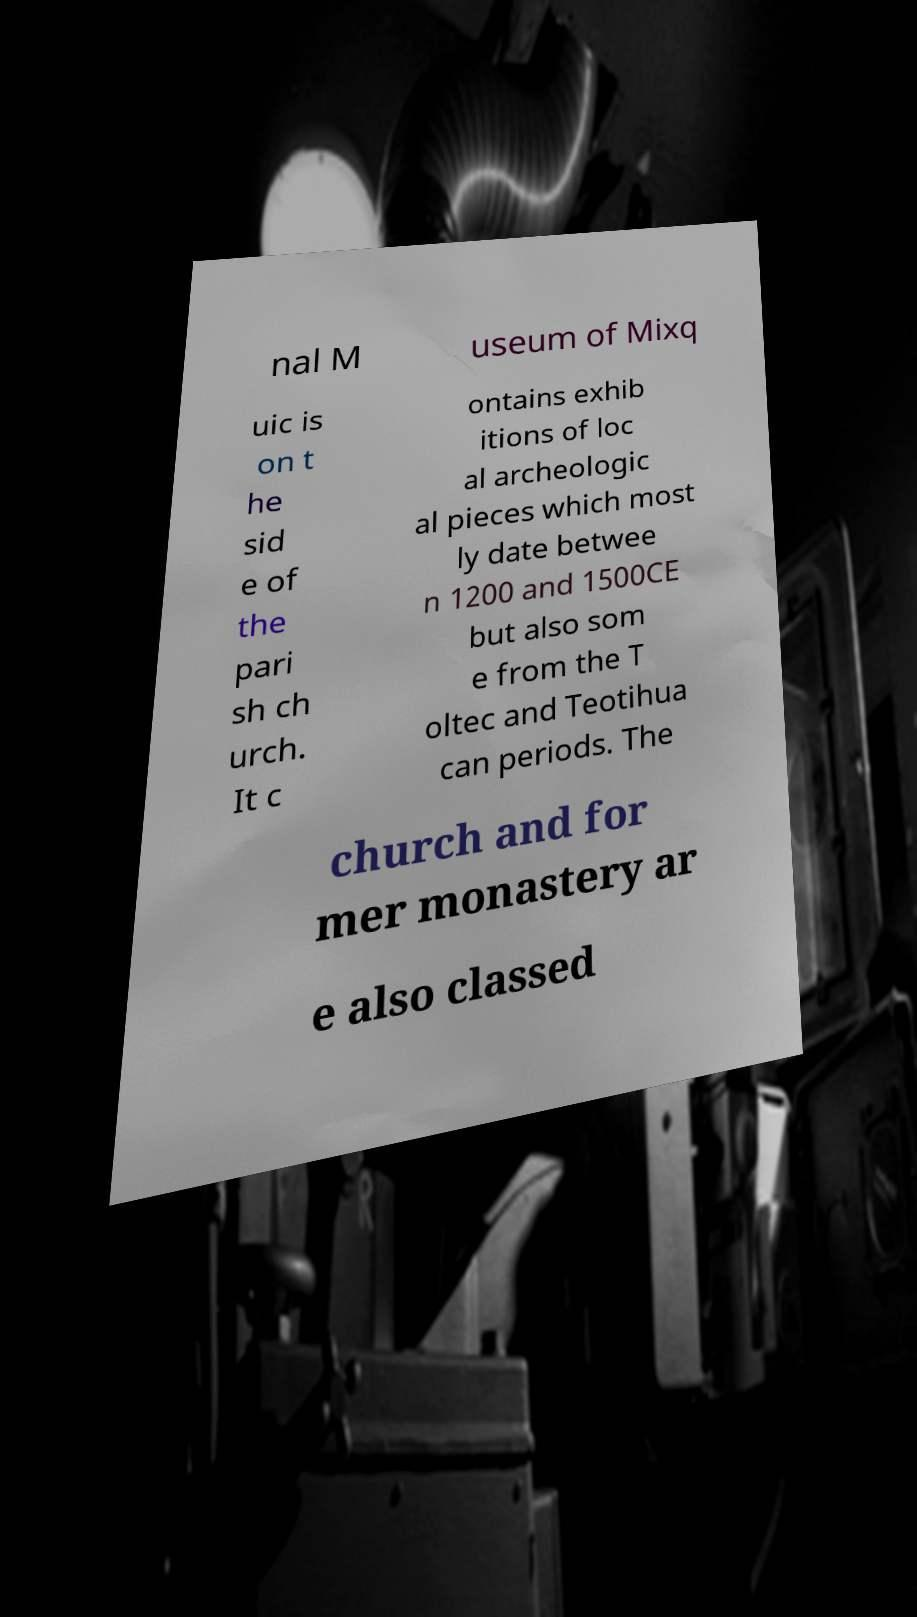Could you assist in decoding the text presented in this image and type it out clearly? nal M useum of Mixq uic is on t he sid e of the pari sh ch urch. It c ontains exhib itions of loc al archeologic al pieces which most ly date betwee n 1200 and 1500CE but also som e from the T oltec and Teotihua can periods. The church and for mer monastery ar e also classed 